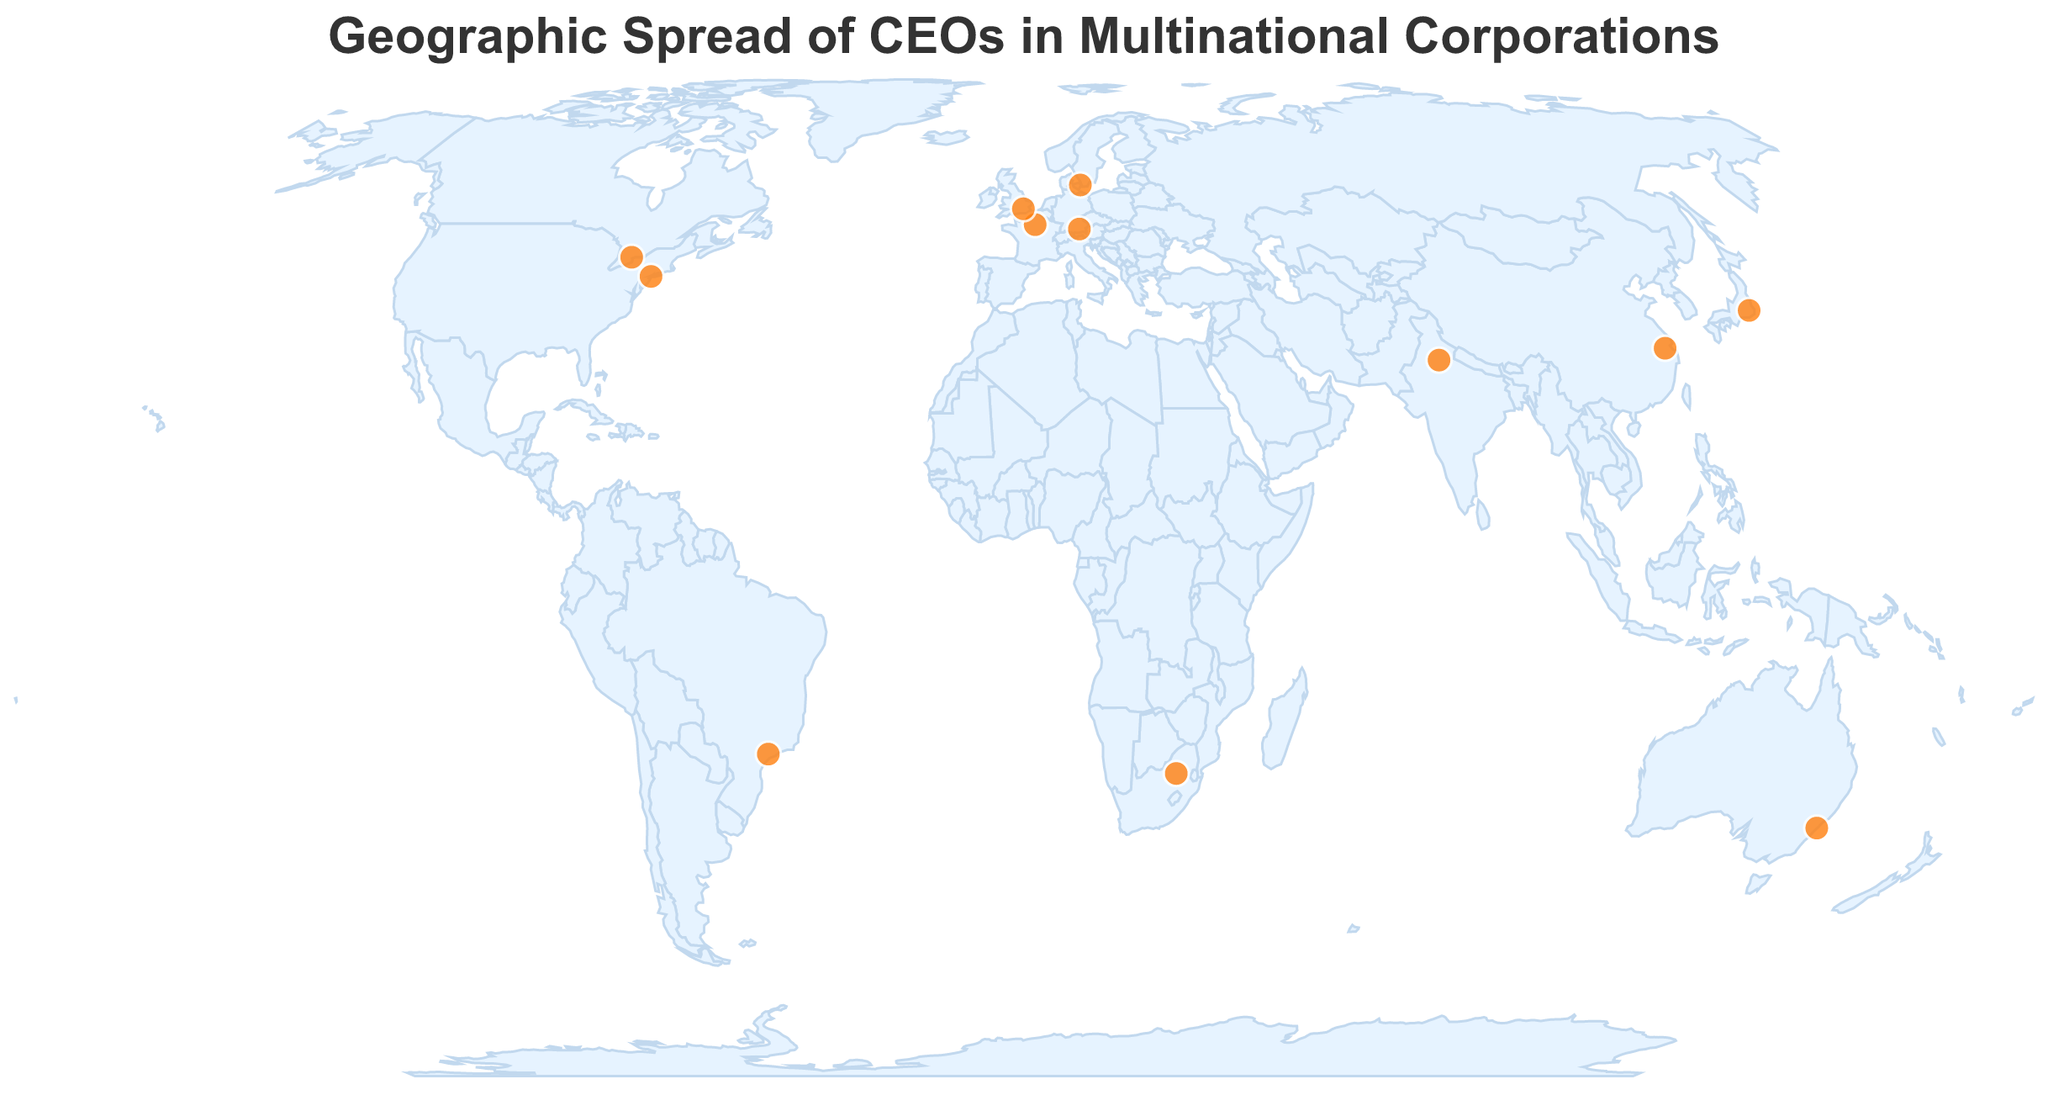What is the title of the figure? The title is typically placed at the top of the figure and is meant to describe what the figure represents. For this plot, the title is "Geographic Spread of CEOs in Multinational Corporations" which can be found at the top of the chart.
Answer: Geographic Spread of CEOs in Multinational Corporations How many female CEOs are depicted in the figure? You need to count the data points where the CEO's name corresponds to a female. From the given data, only two female names are present: Carolina Dybeck Happe in Denmark and Emma Walmsley in the UK.
Answer: 2 Which countries have female CEOs according to the plot? By looking at the tooltip information in the plot and identifying the countries associated with female CEOs, we find that Denmark (Carolina Dybeck Happe) and the UK (Emma Walmsley) have female CEOs.
Answer: Denmark, UK What industry has the highest number of female CEOs? From the given data, only the Shipping (Maersk) and Pharmaceuticals (GSK) industries have female CEOs. Compare the frequency of these industries in the plot.
Answer: Pharmaceuticals How many industries are represented by companies in the USA, and which are they? Identify the data points that are in the USA by their coordinates and count the distinct "Industry" values. The USA is represented by Technology (IBM).
Answer: 1, Technology Which data point is located in Europe, and what is the industry? By referencing the geographic coordinates and identifying the European countries based on their locations, the data points located in Europe are: Denmark (Shipping) and Germany (Automotive). Verify their industries from the tooltip.
Answer: Denmark (Shipping), Germany (Automotive) Compare the number of companies led by female CEOs in the Americas versus Europe. Count the instances of female CEOs in Americas (USA, Canada, Brazil) and Europe (UK, Denmark, France, Germany), then compare. In the Americas, there are 0 female CEOs, whereas in Europe, there are 2 female CEOs (Denmark, UK).
Answer: Europe has more female CEOs (2) than the Americas (0) Which continent has the highest concentration of companies led by female CEOs? By counting the data points categorized by continent and focusing on the ones with female CEOs, Europe (Denmark and UK) has the highest concentration given the data.
Answer: Europe What is a common characteristic of the industries led by female CEOs? Both female CEOs in the dataset lead companies in different industries: Carolina Dybeck Happe in Shipping (Denmark) and Emma Walmsley in Pharmaceuticals (UK). This shows a lack of concentration in any specific industry.
Answer: Different industries How are the companies distributed globally based on their latitude and longitude? Observe the geographic spread within the plot. Companies are distributed across six continents: North America (USA, Canada), South America (Brazil), Europe (Denmark, UK, Germany, France), Asia (China, India, Japan), Africa (South Africa), and Australia (Australia).
Answer: Distributed across six continents 